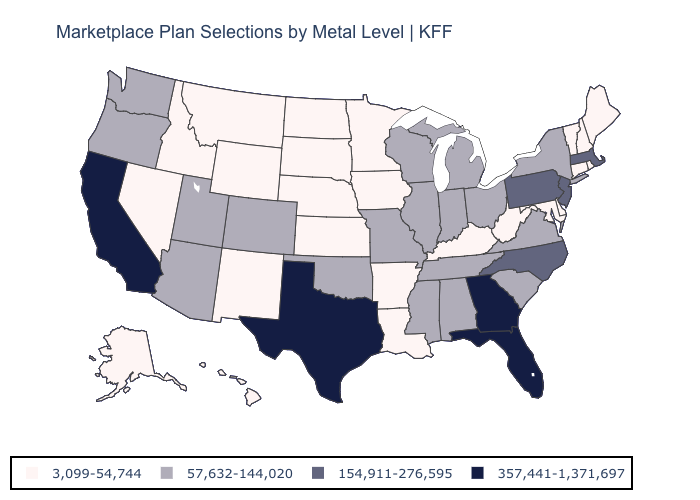Among the states that border Oregon , which have the highest value?
Concise answer only. California. What is the highest value in the USA?
Give a very brief answer. 357,441-1,371,697. Is the legend a continuous bar?
Give a very brief answer. No. What is the highest value in states that border Maryland?
Give a very brief answer. 154,911-276,595. Which states have the lowest value in the USA?
Give a very brief answer. Alaska, Arkansas, Connecticut, Delaware, Hawaii, Idaho, Iowa, Kansas, Kentucky, Louisiana, Maine, Maryland, Minnesota, Montana, Nebraska, Nevada, New Hampshire, New Mexico, North Dakota, Rhode Island, South Dakota, Vermont, West Virginia, Wyoming. Does Connecticut have the same value as California?
Quick response, please. No. Among the states that border Virginia , which have the lowest value?
Quick response, please. Kentucky, Maryland, West Virginia. Does Maine have the lowest value in the USA?
Give a very brief answer. Yes. Name the states that have a value in the range 3,099-54,744?
Answer briefly. Alaska, Arkansas, Connecticut, Delaware, Hawaii, Idaho, Iowa, Kansas, Kentucky, Louisiana, Maine, Maryland, Minnesota, Montana, Nebraska, Nevada, New Hampshire, New Mexico, North Dakota, Rhode Island, South Dakota, Vermont, West Virginia, Wyoming. What is the value of North Dakota?
Answer briefly. 3,099-54,744. Which states have the lowest value in the USA?
Quick response, please. Alaska, Arkansas, Connecticut, Delaware, Hawaii, Idaho, Iowa, Kansas, Kentucky, Louisiana, Maine, Maryland, Minnesota, Montana, Nebraska, Nevada, New Hampshire, New Mexico, North Dakota, Rhode Island, South Dakota, Vermont, West Virginia, Wyoming. What is the lowest value in states that border Louisiana?
Answer briefly. 3,099-54,744. What is the value of Washington?
Keep it brief. 57,632-144,020. Among the states that border Texas , which have the highest value?
Be succinct. Oklahoma. Among the states that border West Virginia , which have the lowest value?
Answer briefly. Kentucky, Maryland. 